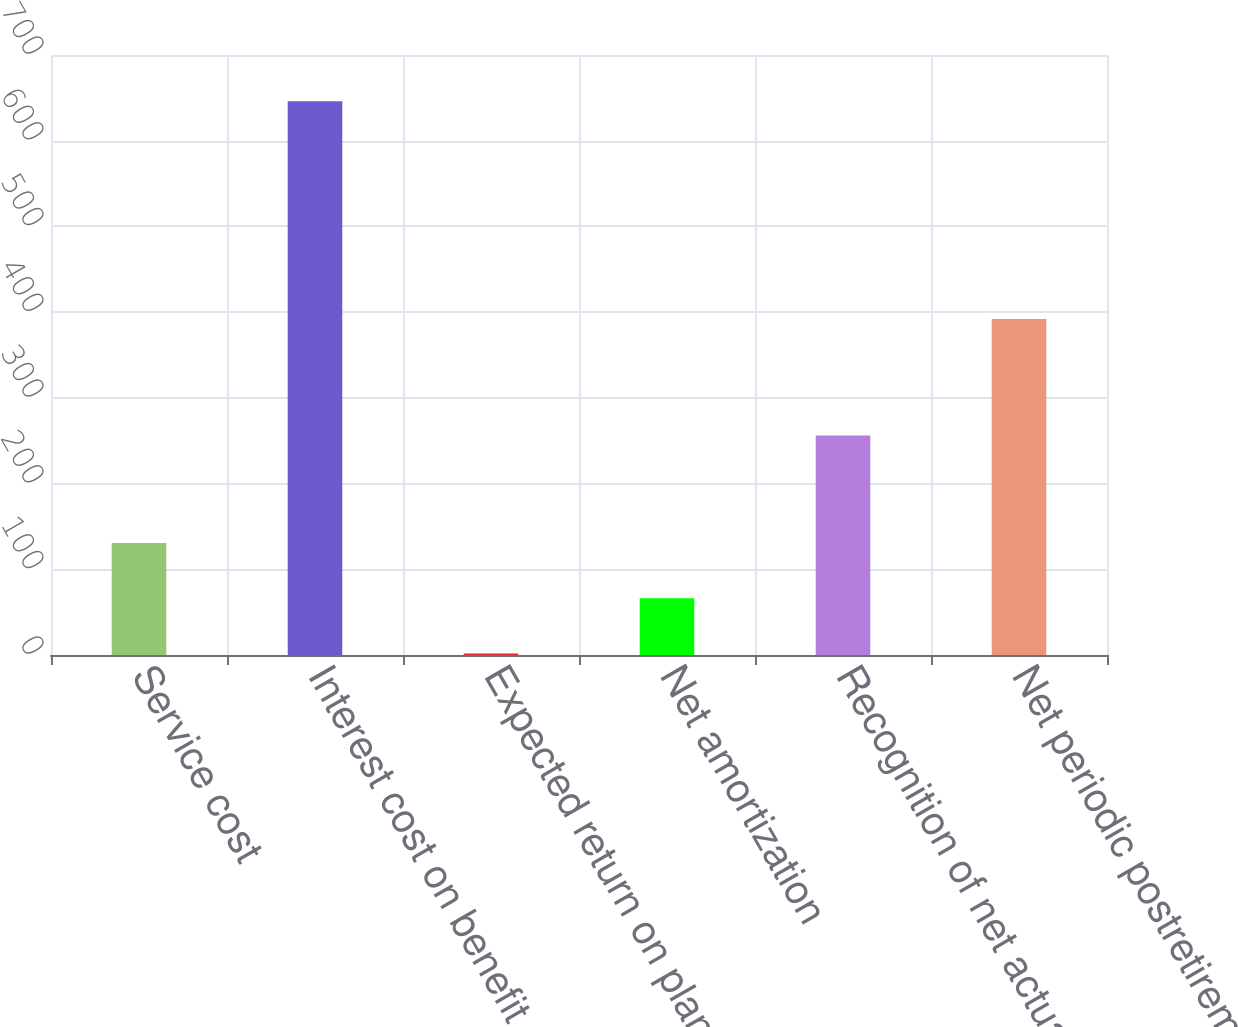Convert chart to OTSL. <chart><loc_0><loc_0><loc_500><loc_500><bar_chart><fcel>Service cost<fcel>Interest cost on benefit<fcel>Expected return on plan assets<fcel>Net amortization<fcel>Recognition of net actuarial<fcel>Net periodic postretirement<nl><fcel>130.64<fcel>646<fcel>1.8<fcel>66.22<fcel>256<fcel>392<nl></chart> 